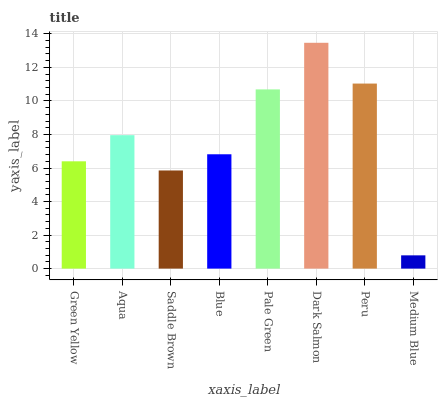Is Medium Blue the minimum?
Answer yes or no. Yes. Is Dark Salmon the maximum?
Answer yes or no. Yes. Is Aqua the minimum?
Answer yes or no. No. Is Aqua the maximum?
Answer yes or no. No. Is Aqua greater than Green Yellow?
Answer yes or no. Yes. Is Green Yellow less than Aqua?
Answer yes or no. Yes. Is Green Yellow greater than Aqua?
Answer yes or no. No. Is Aqua less than Green Yellow?
Answer yes or no. No. Is Aqua the high median?
Answer yes or no. Yes. Is Blue the low median?
Answer yes or no. Yes. Is Dark Salmon the high median?
Answer yes or no. No. Is Medium Blue the low median?
Answer yes or no. No. 